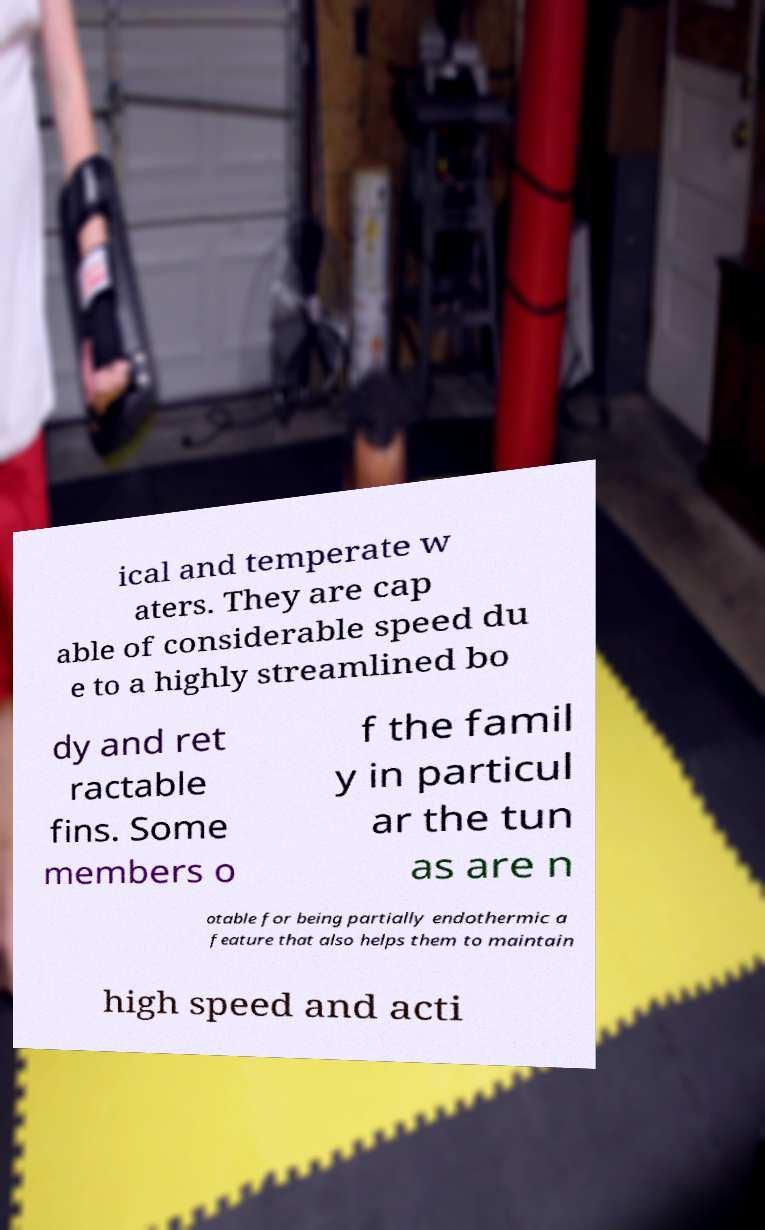For documentation purposes, I need the text within this image transcribed. Could you provide that? ical and temperate w aters. They are cap able of considerable speed du e to a highly streamlined bo dy and ret ractable fins. Some members o f the famil y in particul ar the tun as are n otable for being partially endothermic a feature that also helps them to maintain high speed and acti 